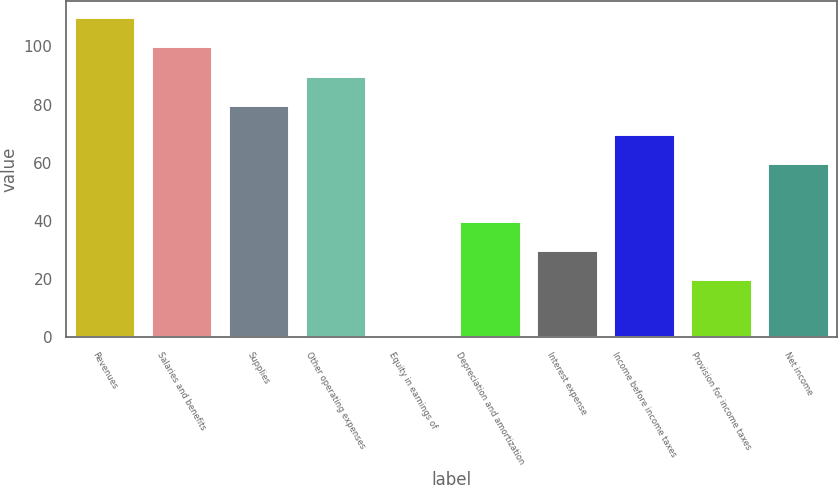Convert chart to OTSL. <chart><loc_0><loc_0><loc_500><loc_500><bar_chart><fcel>Revenues<fcel>Salaries and benefits<fcel>Supplies<fcel>Other operating expenses<fcel>Equity in earnings of<fcel>Depreciation and amortization<fcel>Interest expense<fcel>Income before income taxes<fcel>Provision for income taxes<fcel>Net income<nl><fcel>109.99<fcel>100<fcel>80.02<fcel>90.01<fcel>0.1<fcel>40.06<fcel>30.07<fcel>70.03<fcel>20.08<fcel>60.04<nl></chart> 